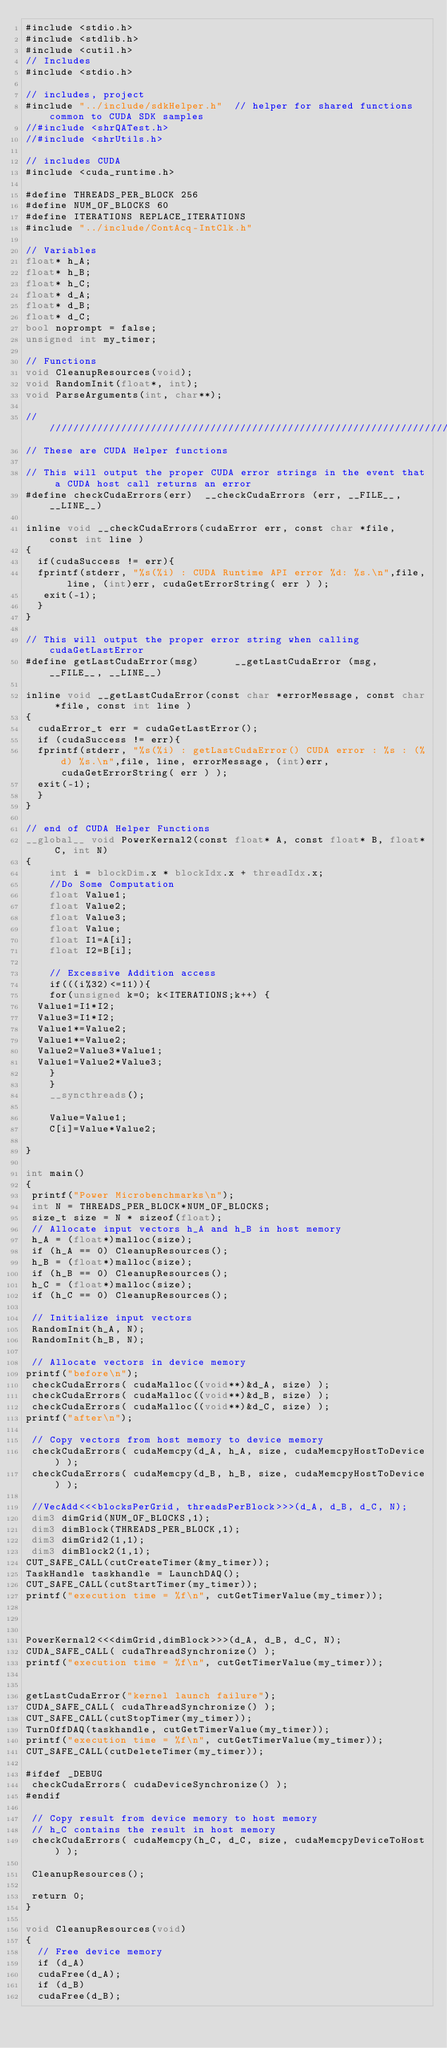<code> <loc_0><loc_0><loc_500><loc_500><_Cuda_>#include <stdio.h>
#include <stdlib.h>
#include <cutil.h>
// Includes
#include <stdio.h>

// includes, project
#include "../include/sdkHelper.h"  // helper for shared functions common to CUDA SDK samples
//#include <shrQATest.h>
//#include <shrUtils.h>

// includes CUDA
#include <cuda_runtime.h>

#define THREADS_PER_BLOCK 256
#define NUM_OF_BLOCKS 60
#define ITERATIONS REPLACE_ITERATIONS
#include "../include/ContAcq-IntClk.h"

// Variables
float* h_A;
float* h_B;
float* h_C;
float* d_A;
float* d_B;
float* d_C;
bool noprompt = false;
unsigned int my_timer;

// Functions
void CleanupResources(void);
void RandomInit(float*, int);
void ParseArguments(int, char**);

////////////////////////////////////////////////////////////////////////////////
// These are CUDA Helper functions

// This will output the proper CUDA error strings in the event that a CUDA host call returns an error
#define checkCudaErrors(err)  __checkCudaErrors (err, __FILE__, __LINE__)

inline void __checkCudaErrors(cudaError err, const char *file, const int line )
{
  if(cudaSuccess != err){
	fprintf(stderr, "%s(%i) : CUDA Runtime API error %d: %s.\n",file, line, (int)err, cudaGetErrorString( err ) );
	 exit(-1);
  }
}

// This will output the proper error string when calling cudaGetLastError
#define getLastCudaError(msg)      __getLastCudaError (msg, __FILE__, __LINE__)

inline void __getLastCudaError(const char *errorMessage, const char *file, const int line )
{
  cudaError_t err = cudaGetLastError();
  if (cudaSuccess != err){
	fprintf(stderr, "%s(%i) : getLastCudaError() CUDA error : %s : (%d) %s.\n",file, line, errorMessage, (int)err, cudaGetErrorString( err ) );
	exit(-1);
  }
}

// end of CUDA Helper Functions
__global__ void PowerKernal2(const float* A, const float* B, float* C, int N)
{
    int i = blockDim.x * blockIdx.x + threadIdx.x;
    //Do Some Computation
    float Value1;
    float Value2;
    float Value3;
    float Value;
    float I1=A[i];
    float I2=B[i];

    // Excessive Addition access
    if(((i%32)<=11)){
    for(unsigned k=0; k<ITERATIONS;k++) {
	Value1=I1*I2;
	Value3=I1*I2;
	Value1*=Value2;
	Value1*=Value2;
	Value2=Value3*Value1;
	Value1=Value2*Value3;
    }
    }
    __syncthreads();

    Value=Value1;
    C[i]=Value*Value2;

}

int main()
{
 printf("Power Microbenchmarks\n");
 int N = THREADS_PER_BLOCK*NUM_OF_BLOCKS;
 size_t size = N * sizeof(float);
 // Allocate input vectors h_A and h_B in host memory
 h_A = (float*)malloc(size);
 if (h_A == 0) CleanupResources();
 h_B = (float*)malloc(size);
 if (h_B == 0) CleanupResources();
 h_C = (float*)malloc(size);
 if (h_C == 0) CleanupResources();

 // Initialize input vectors
 RandomInit(h_A, N);
 RandomInit(h_B, N);

 // Allocate vectors in device memory
printf("before\n");
 checkCudaErrors( cudaMalloc((void**)&d_A, size) );
 checkCudaErrors( cudaMalloc((void**)&d_B, size) );
 checkCudaErrors( cudaMalloc((void**)&d_C, size) );
printf("after\n");

 // Copy vectors from host memory to device memory
 checkCudaErrors( cudaMemcpy(d_A, h_A, size, cudaMemcpyHostToDevice) );
 checkCudaErrors( cudaMemcpy(d_B, h_B, size, cudaMemcpyHostToDevice) );

 //VecAdd<<<blocksPerGrid, threadsPerBlock>>>(d_A, d_B, d_C, N);
 dim3 dimGrid(NUM_OF_BLOCKS,1);
 dim3 dimBlock(THREADS_PER_BLOCK,1);
 dim3 dimGrid2(1,1);
 dim3 dimBlock2(1,1);
CUT_SAFE_CALL(cutCreateTimer(&my_timer)); 
TaskHandle taskhandle = LaunchDAQ();
CUT_SAFE_CALL(cutStartTimer(my_timer)); 
printf("execution time = %f\n", cutGetTimerValue(my_timer));



PowerKernal2<<<dimGrid,dimBlock>>>(d_A, d_B, d_C, N);
CUDA_SAFE_CALL( cudaThreadSynchronize() );
printf("execution time = %f\n", cutGetTimerValue(my_timer));


getLastCudaError("kernel launch failure");
CUDA_SAFE_CALL( cudaThreadSynchronize() );
CUT_SAFE_CALL(cutStopTimer(my_timer));
TurnOffDAQ(taskhandle, cutGetTimerValue(my_timer));
printf("execution time = %f\n", cutGetTimerValue(my_timer));
CUT_SAFE_CALL(cutDeleteTimer(my_timer)); 

#ifdef _DEBUG
 checkCudaErrors( cudaDeviceSynchronize() );
#endif

 // Copy result from device memory to host memory
 // h_C contains the result in host memory
 checkCudaErrors( cudaMemcpy(h_C, d_C, size, cudaMemcpyDeviceToHost) );
 
 CleanupResources();

 return 0;
}

void CleanupResources(void)
{
  // Free device memory
  if (d_A)
	cudaFree(d_A);
  if (d_B)
	cudaFree(d_B);</code> 